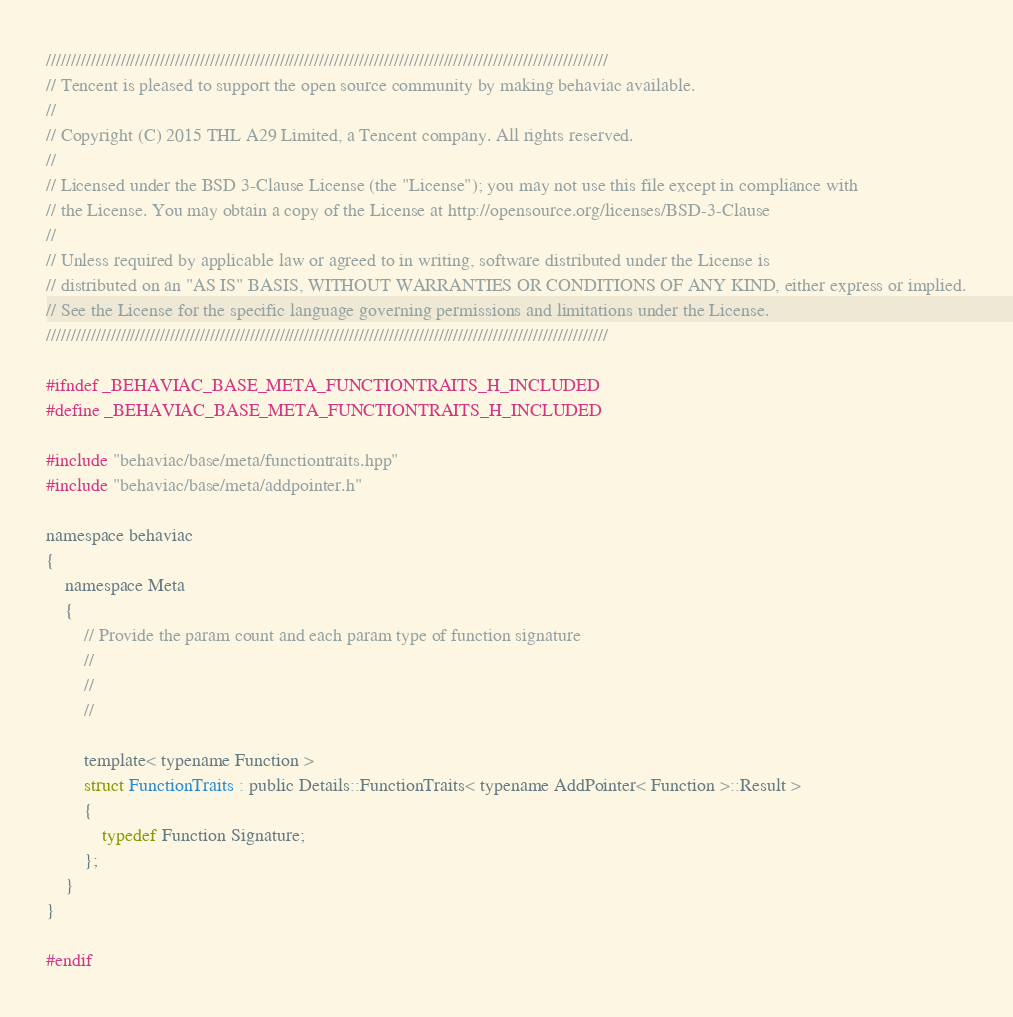<code> <loc_0><loc_0><loc_500><loc_500><_C_>/////////////////////////////////////////////////////////////////////////////////////////////////////////////////
// Tencent is pleased to support the open source community by making behaviac available.
//
// Copyright (C) 2015 THL A29 Limited, a Tencent company. All rights reserved.
//
// Licensed under the BSD 3-Clause License (the "License"); you may not use this file except in compliance with
// the License. You may obtain a copy of the License at http://opensource.org/licenses/BSD-3-Clause
//
// Unless required by applicable law or agreed to in writing, software distributed under the License is
// distributed on an "AS IS" BASIS, WITHOUT WARRANTIES OR CONDITIONS OF ANY KIND, either express or implied.
// See the License for the specific language governing permissions and limitations under the License.
/////////////////////////////////////////////////////////////////////////////////////////////////////////////////

#ifndef _BEHAVIAC_BASE_META_FUNCTIONTRAITS_H_INCLUDED
#define _BEHAVIAC_BASE_META_FUNCTIONTRAITS_H_INCLUDED

#include "behaviac/base/meta/functiontraits.hpp"
#include "behaviac/base/meta/addpointer.h"

namespace behaviac
{
    namespace Meta
    {
        // Provide the param count and each param type of function signature
        //
        //
        //

        template< typename Function >
        struct FunctionTraits : public Details::FunctionTraits< typename AddPointer< Function >::Result >
        {
            typedef Function Signature;
        };
    }
}

#endif
</code> 